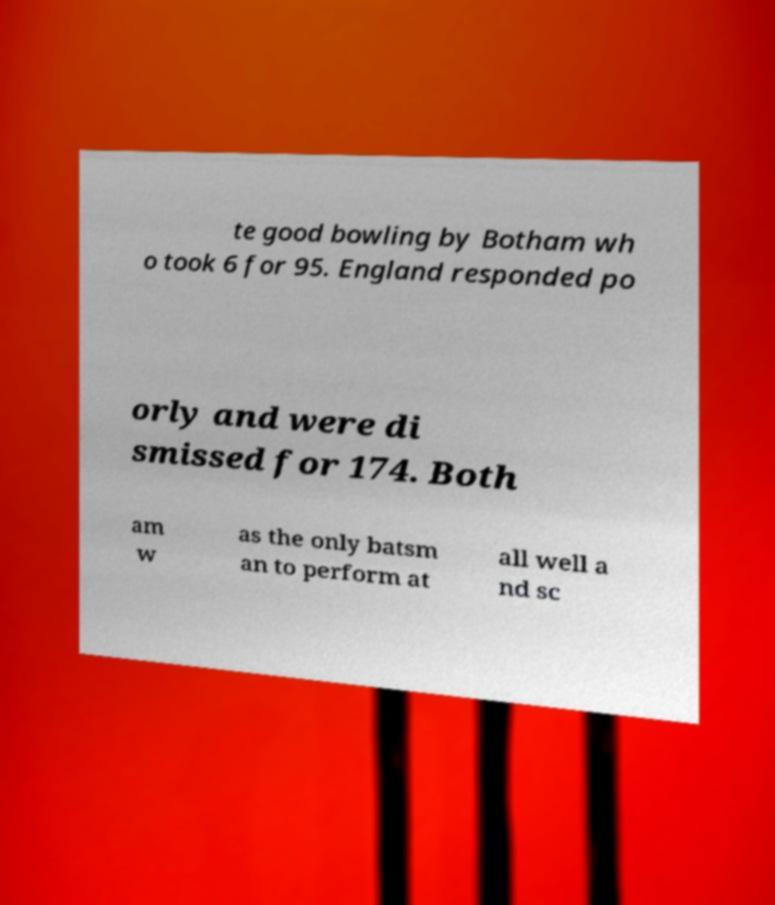What messages or text are displayed in this image? I need them in a readable, typed format. te good bowling by Botham wh o took 6 for 95. England responded po orly and were di smissed for 174. Both am w as the only batsm an to perform at all well a nd sc 